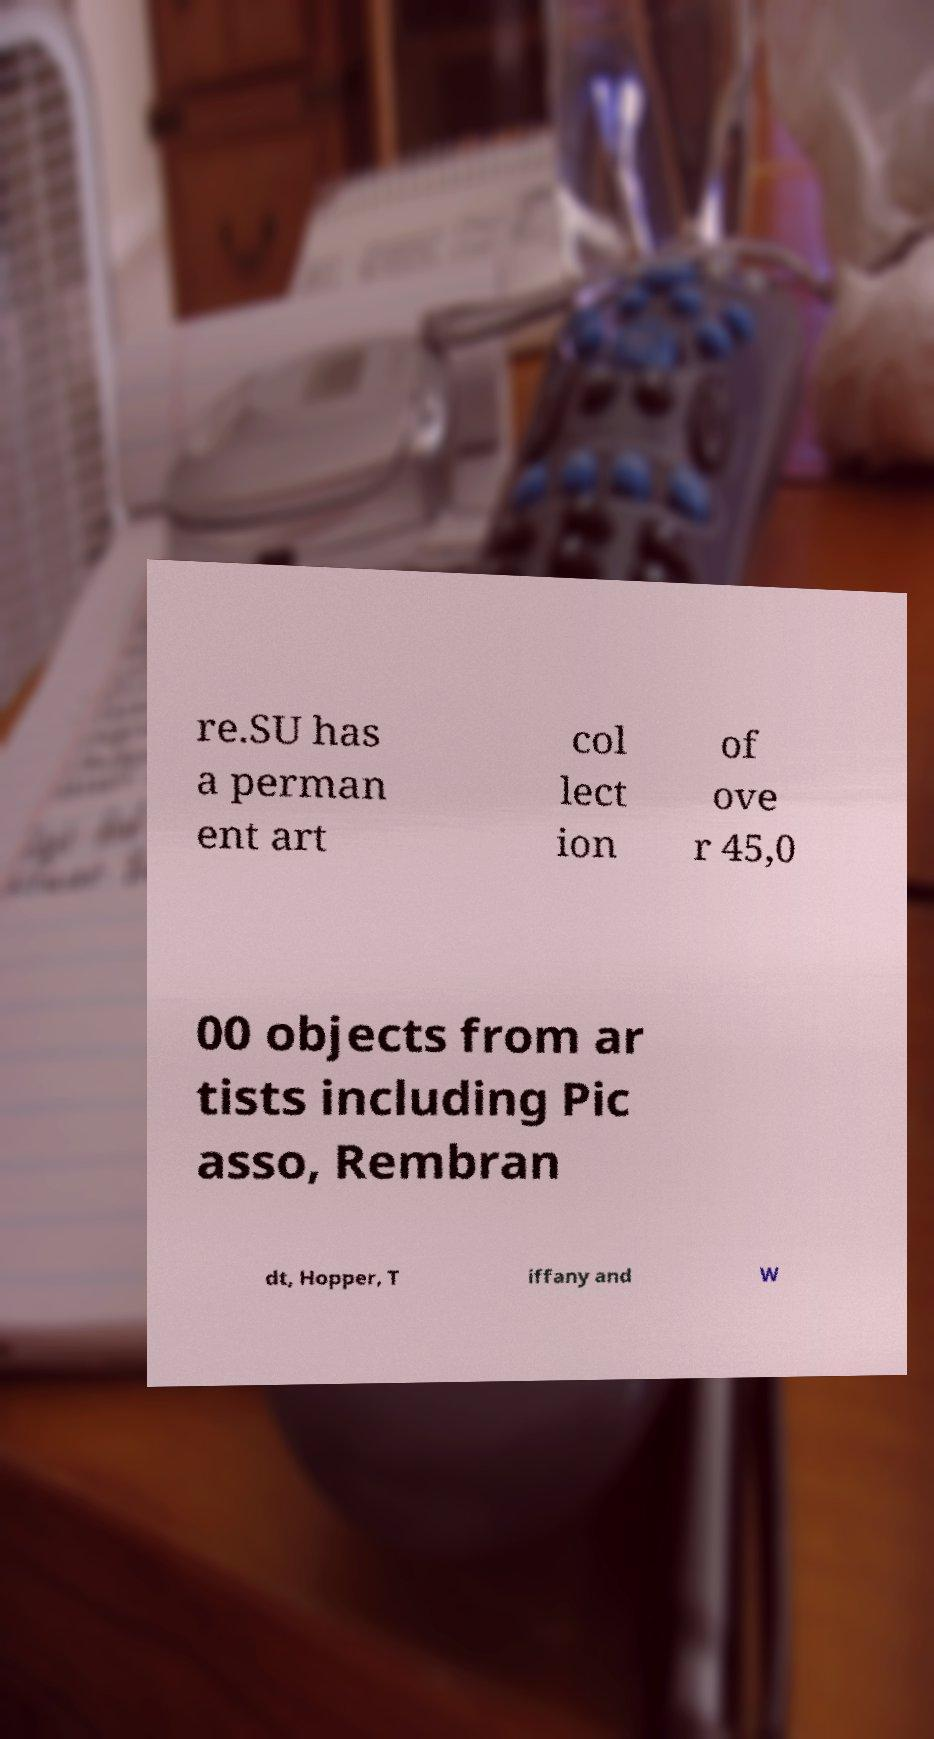For documentation purposes, I need the text within this image transcribed. Could you provide that? re.SU has a perman ent art col lect ion of ove r 45,0 00 objects from ar tists including Pic asso, Rembran dt, Hopper, T iffany and W 